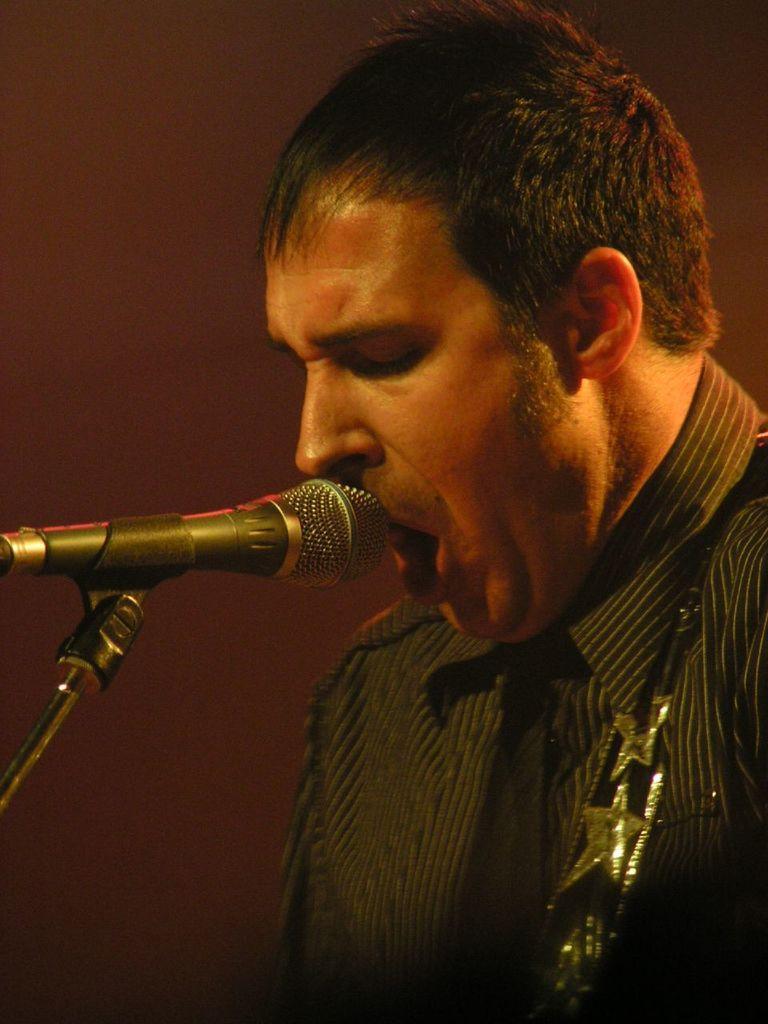Could you give a brief overview of what you see in this image? In this image we can see a person. In front of him there is a mic with mic stand. In the background it is dark. 